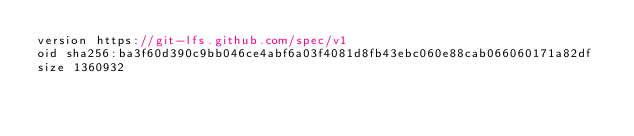Convert code to text. <code><loc_0><loc_0><loc_500><loc_500><_TypeScript_>version https://git-lfs.github.com/spec/v1
oid sha256:ba3f60d390c9bb046ce4abf6a03f4081d8fb43ebc060e88cab066060171a82df
size 1360932
</code> 